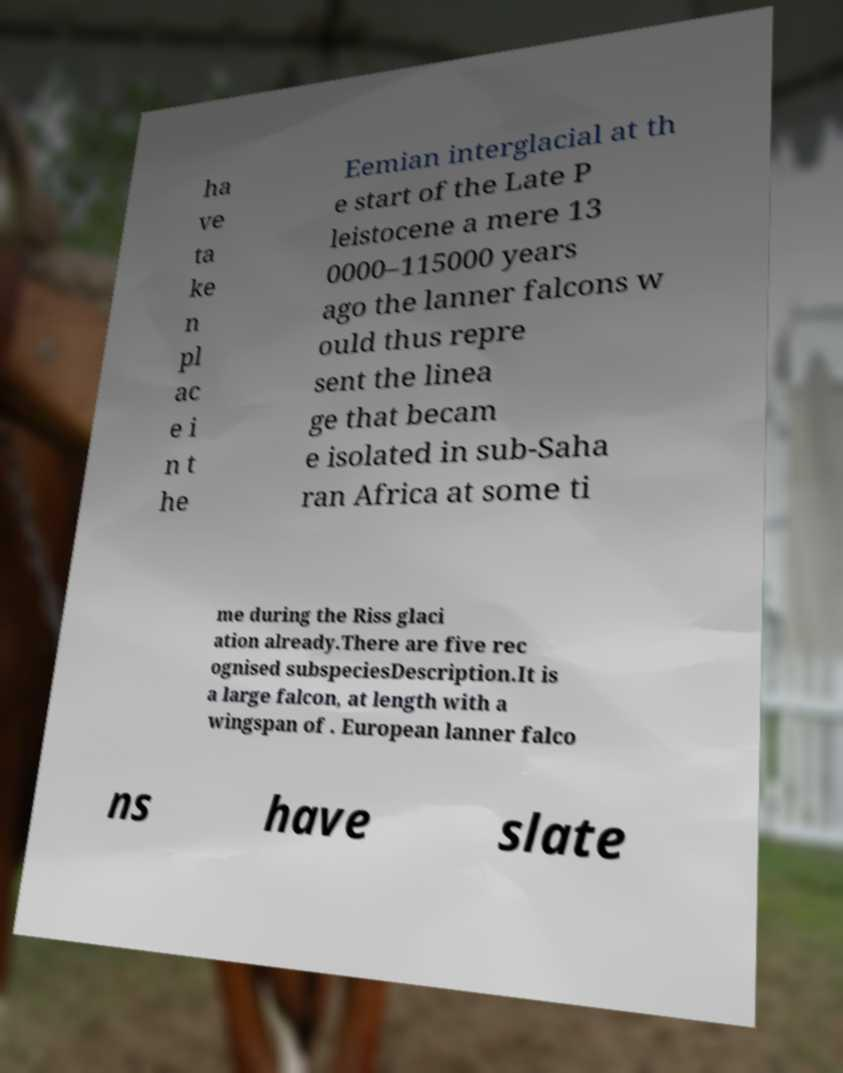Can you accurately transcribe the text from the provided image for me? ha ve ta ke n pl ac e i n t he Eemian interglacial at th e start of the Late P leistocene a mere 13 0000–115000 years ago the lanner falcons w ould thus repre sent the linea ge that becam e isolated in sub-Saha ran Africa at some ti me during the Riss glaci ation already.There are five rec ognised subspeciesDescription.It is a large falcon, at length with a wingspan of . European lanner falco ns have slate 